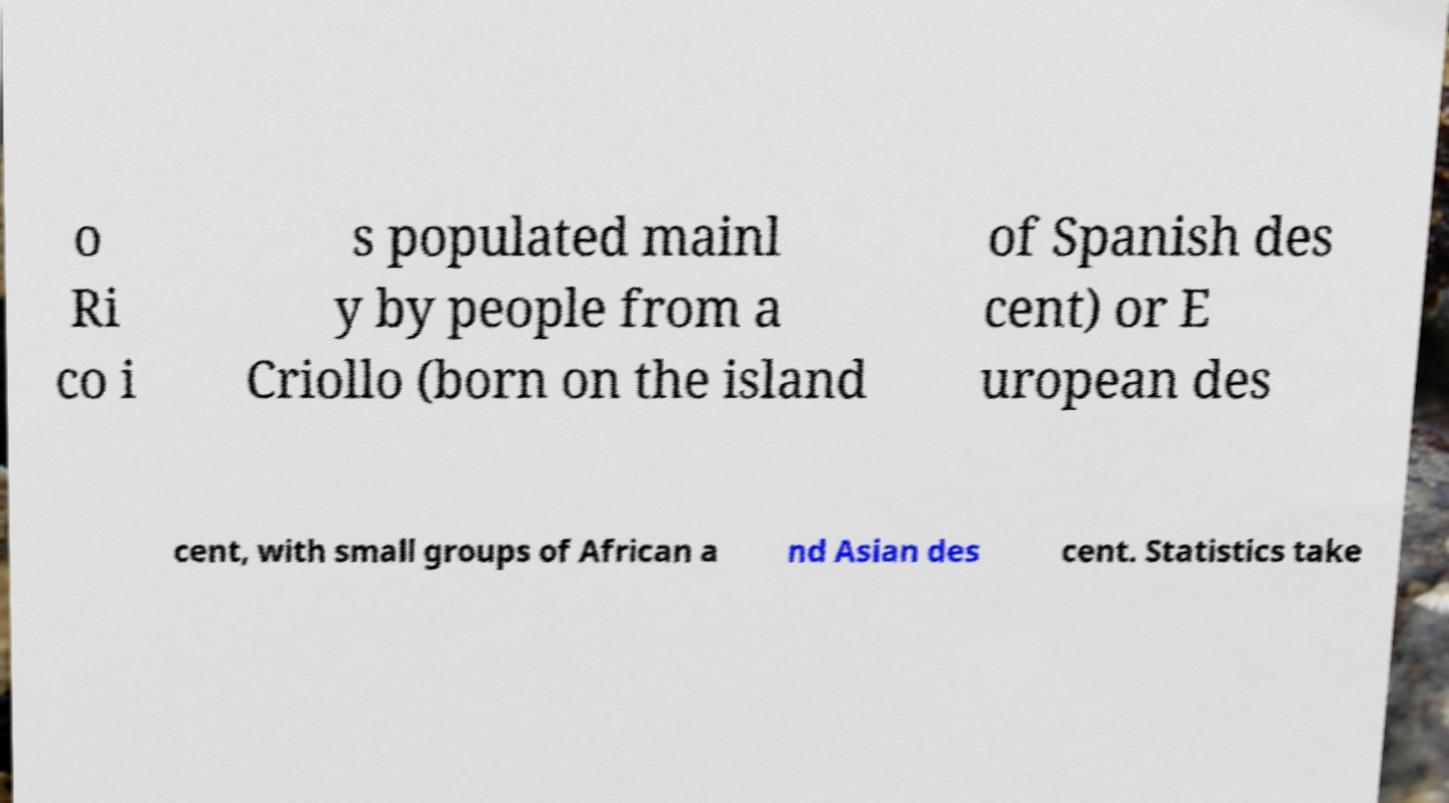There's text embedded in this image that I need extracted. Can you transcribe it verbatim? o Ri co i s populated mainl y by people from a Criollo (born on the island of Spanish des cent) or E uropean des cent, with small groups of African a nd Asian des cent. Statistics take 